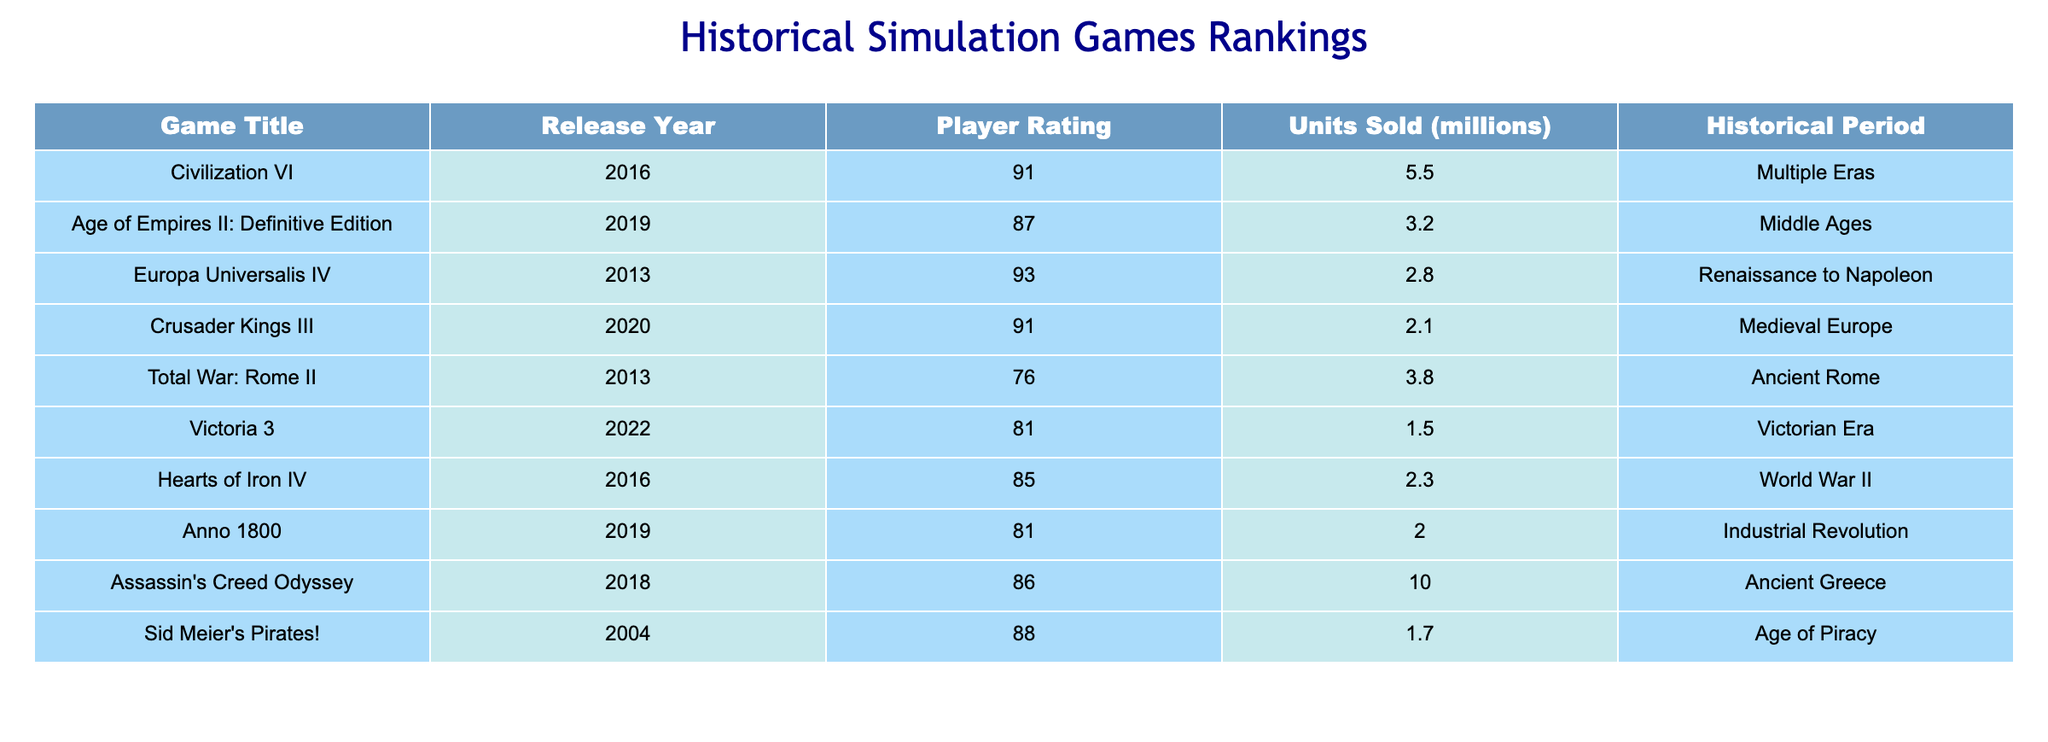What is the player rating of Civilization VI? The player rating of Civilization VI is explicitly listed in the table under the "Player Rating" column. Simply find the row corresponding to Civilization VI and read the value next to it.
Answer: 91 Which game sold the most units? By comparing the values in the "Units Sold (millions)" column across all games, it is clear that Assassin's Creed Odyssey has the highest value of 10.0 million units sold.
Answer: Assassin's Creed Odyssey What is the average player rating of the games listed? To calculate the average player rating, sum all player ratings: (91 + 87 + 93 + 91 + 76 + 81 + 85 + 81 + 86 + 88) =  918. There are 10 games, so the average is 918 / 10 = 91.8.
Answer: 91.8 Is there a game that is set in the Victorian Era? By scanning the "Historical Period" column, it can be seen that Victoria 3 is specifically set in the Victorian Era. Therefore, yes, there is a game set in the Victorian Era.
Answer: Yes Which historical period has the least games represented in the table? To identify the historical period with the least representation, count the occurrences in the "Historical Period" column. Ancient Greece has 1 game (Assassin's Creed Odyssey), while others have more. Therefore, Ancient Greece has the least representation.
Answer: Ancient Greece What is the difference in units sold between Age of Empires II: Definitive Edition and Total War: Rome II? The units sold for Age of Empires II: Definitive Edition is 3.2 million, and for Total War: Rome II, it is 3.8 million. The difference is calculated as 3.8 - 3.2 = 0.6 million units sold.
Answer: 0.6 million How many games have a player rating above 85? By reviewing the "Player Rating" column, the games with ratings above 85 are: Civilization VI (91), Europa Universalis IV (93), Crusader Kings III (91), and Assassin's Creed Odyssey (86). There are 4 games that meet this criterion.
Answer: 4 What year did the game with the second-highest player rating release? From the table, Europa Universalis IV has the second-highest player rating (93) and was released in 2013. Therefore, the year of release is obtained from the same row where this game is listed.
Answer: 2013 Which game has the lowest player rating, and what is that rating? Checking the table reveals Total War: Rome II with a player rating of 76, which is the lowest among all the games listed.
Answer: Total War: Rome II, 76 